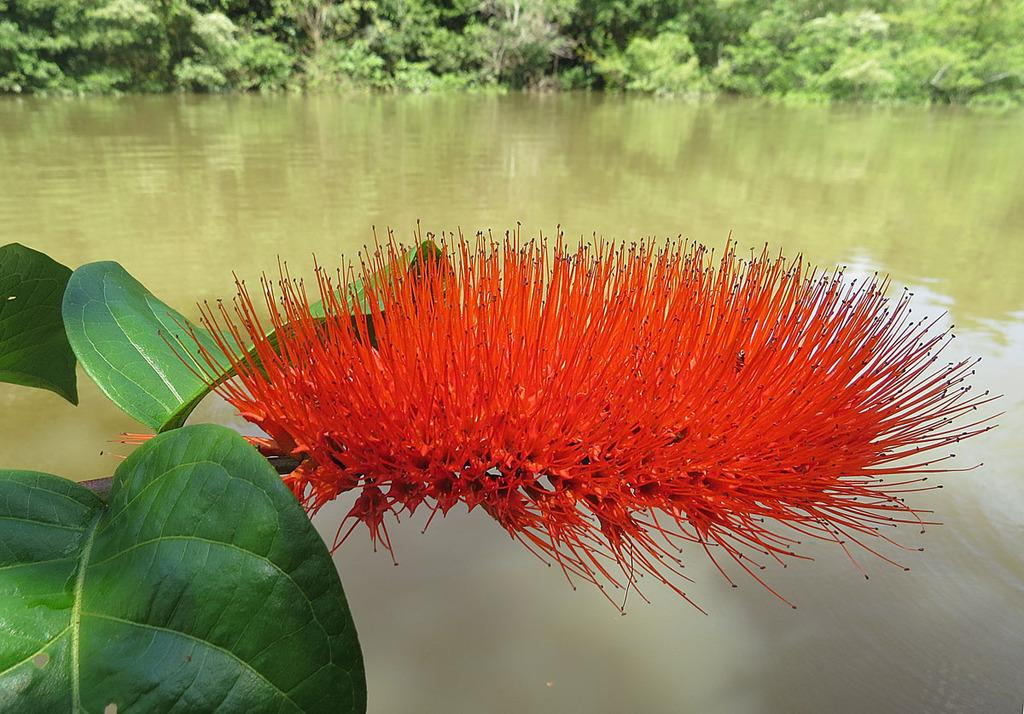What type of plant can be seen in the image? There is a flower in the image. What else is present on the plant besides the flower? There are leaves in the image. What is the primary element visible in the image? There is water visible in the image. What can be seen in the distance in the image? There are trees in the background of the image. What type of animal is hiding in the flower in the image? There is no animal present in the image, and the flower does not appear to be hiding anything. 